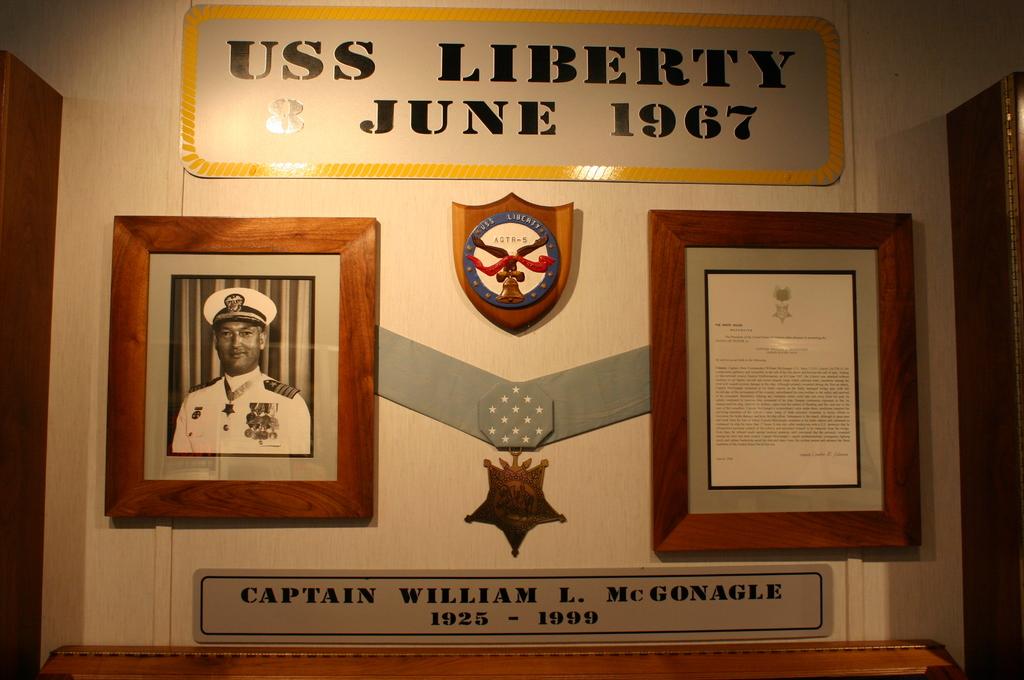What is the man in the photos name?
Make the answer very short. Captain william l. mcgonagle. 